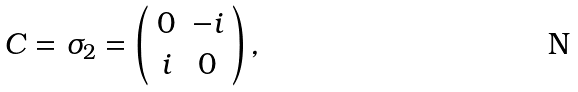<formula> <loc_0><loc_0><loc_500><loc_500>C = \sigma _ { 2 } = \left ( \begin{array} { c c } 0 & - i \\ i & 0 \end{array} \right ) ,</formula> 